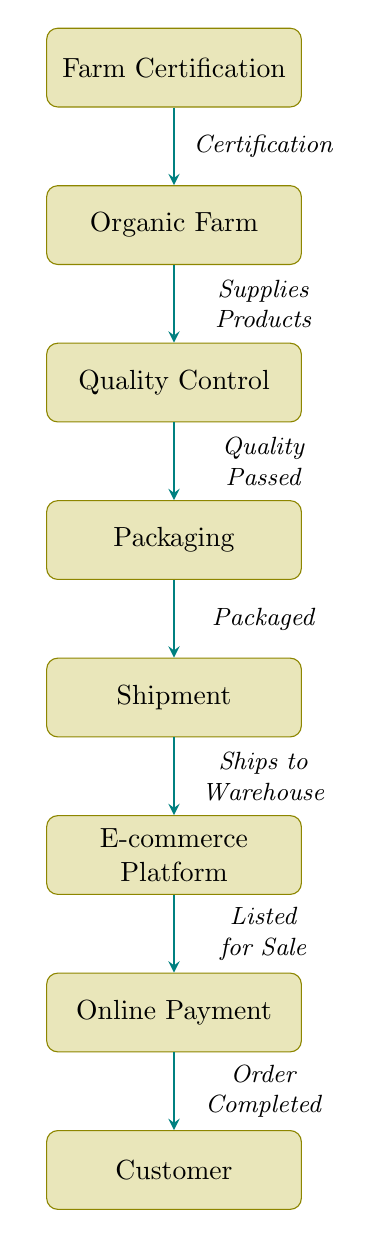What is the first process in the diagram? The diagram starts with the node labeled "Farm Certification," which is the first process listed before all others.
Answer: Farm Certification How many processes are shown in the diagram? By counting each labeled process in the diagram, there are a total of seven processes, from "Farm Certification" to "Customer."
Answer: 7 What relationship exists between the "Organic Farm" and "Quality Control"? The arrow shows that the "Organic Farm" supplies products to "Quality Control," indicating a direct relationship in the flow.
Answer: Supplies Products Which process comes directly after "Packaging"? The process that follows "Packaging" in the order of the diagram is "Shipment." This is evident from the downward arrangement of the nodes.
Answer: Shipment What must happen after "Quality Control" and before "Packaging"? According to the flow, there must be a "Quality Passed" status that confirms products have met the required standards before they can be packaged.
Answer: Quality Passed What is the last step before the customer receives their order? The last process before the customer receives their order is "Online Payment," which indicates that payment must be completed before the final fulfillment.
Answer: Online Payment How is the e-commerce platform related to the overall process? The e-commerce platform serves to list the products for sale after the products are shipped to the warehouse, indicating its role in facilitating the transaction process.
Answer: Listed for Sale Which two processes are directly connected to the customer? The two processes directly connected to the customer are "Online Payment" and the final step leading to "Customer," which represents the completion of the order process.
Answer: Online Payment, Customer In what sequence does "Shipment" occur in relation to "Packaging"? "Shipment" follows directly after "Packaging" in the order of processes, illustrating the logistical flow from product packaging to shipment.
Answer: After 